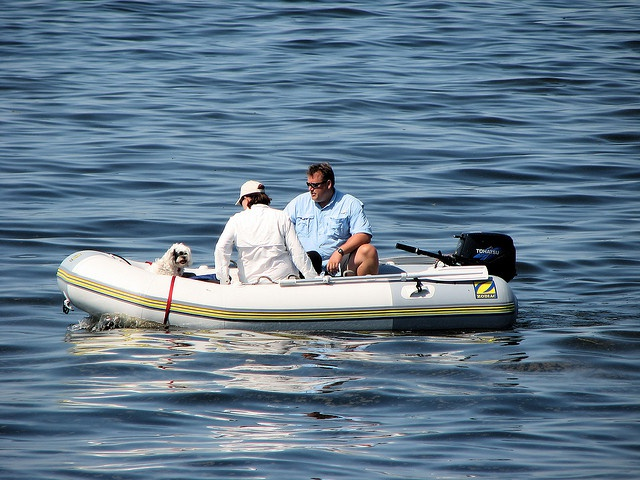Describe the objects in this image and their specific colors. I can see boat in blue, white, black, darkgray, and gray tones, people in blue, white, darkgray, and black tones, people in blue, lightblue, black, and maroon tones, and dog in blue, ivory, gray, darkgray, and black tones in this image. 